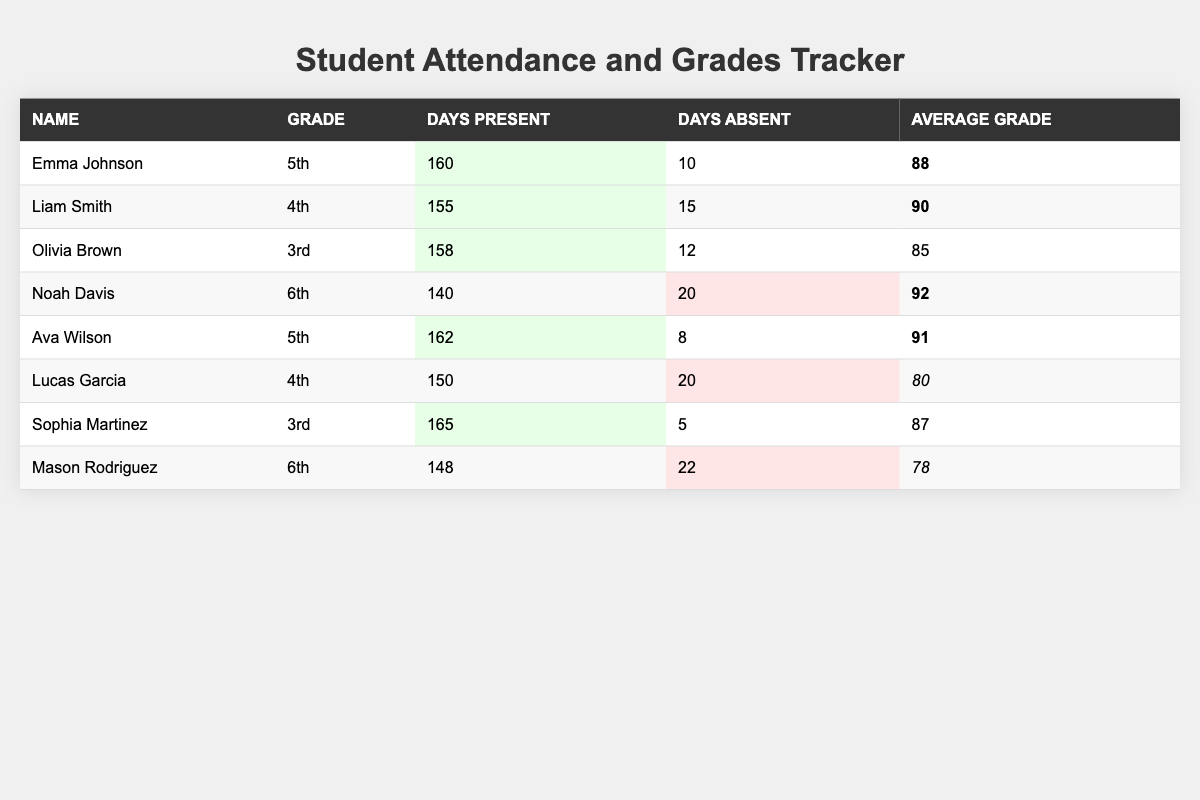What is Emma Johnson's average grade? Emma Johnson's average grade can be found in the table. It is listed in the column under "Average Grade" next to her name. The value is 88.
Answer: 88 How many days was Sophia Martinez absent? Sophia Martinez's days absent can be found in the column under "Days Absent.” She is listed with 5 days absent.
Answer: 5 Which student has the highest average grade? To find the highest average grade, we compare the "Average Grade" column values. Ava Wilson has the highest grade at 91.
Answer: 91 What is the total number of days present for all students? We sum up the "Days Present" column values: 160 + 155 + 158 + 140 + 162 + 150 + 165 + 148 = 1,088.
Answer: 1088 Is Liam Smith absent more than Mason Rodriguez? Liam Smith has 15 days absent and Mason Rodriguez has 22 days absent. Since 15 is less than 22, the statement is false.
Answer: No Who is the only 3rd grader with more than 12 days absent? We look at the "Grade" column for 3rd graders and check their "Days Absent." Olivia Brown has 12 days absent, while Sophia Martinez has only 5. Therefore, no 3rd graders have more than 12 days absent.
Answer: None What is the average attendance for 4th graders? For 4th graders, we find Liam Smith's and Lucas Garcia's attendances: 155 days and 150 days. The average is (155 + 150) / 2 = 152.5.
Answer: 152.5 How many students had better attendance than Noah Davis? Noah Davis had 140 days present. We compare this with the other students: Emma (160), Liam (155), Olivia (158), Ava (162), Lucas (150), Sophia (165), and Mason (148). The total is 6 students.
Answer: 6 Is Ava Wilson's attendance better than 160 days? Ava Wilson's days present are listed as 162, which is greater than 160. Therefore, the statement is true.
Answer: Yes What is the difference between the highest and lowest average grades? The highest average grade is Ava Wilson's 91, and the lowest is Lucas Garcia's 80. The difference is 91 - 80 = 11.
Answer: 11 